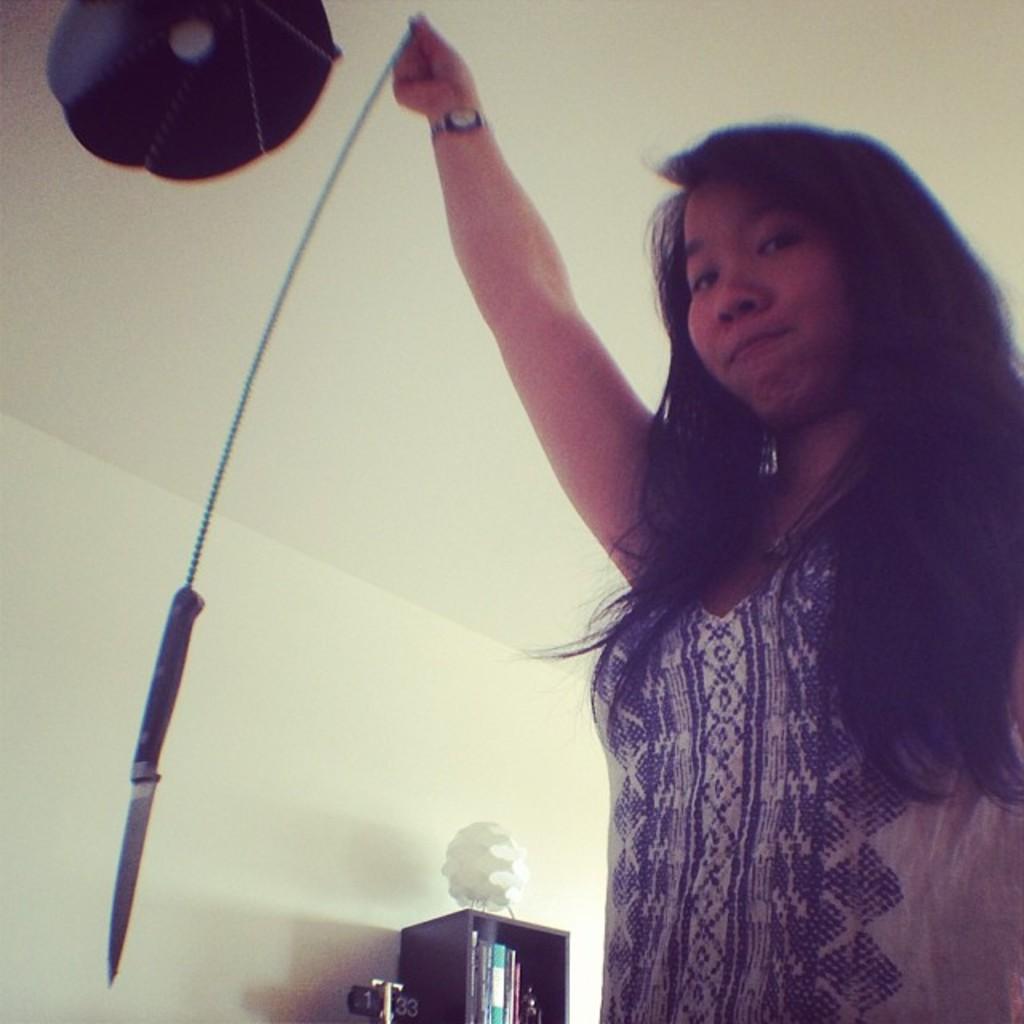Describe this image in one or two sentences. On the right side of the image, we can see a woman is holding an object. Here we can see a knife. Background there is a wall, few objects and things. Left side top of the image, we can see a bulb. 